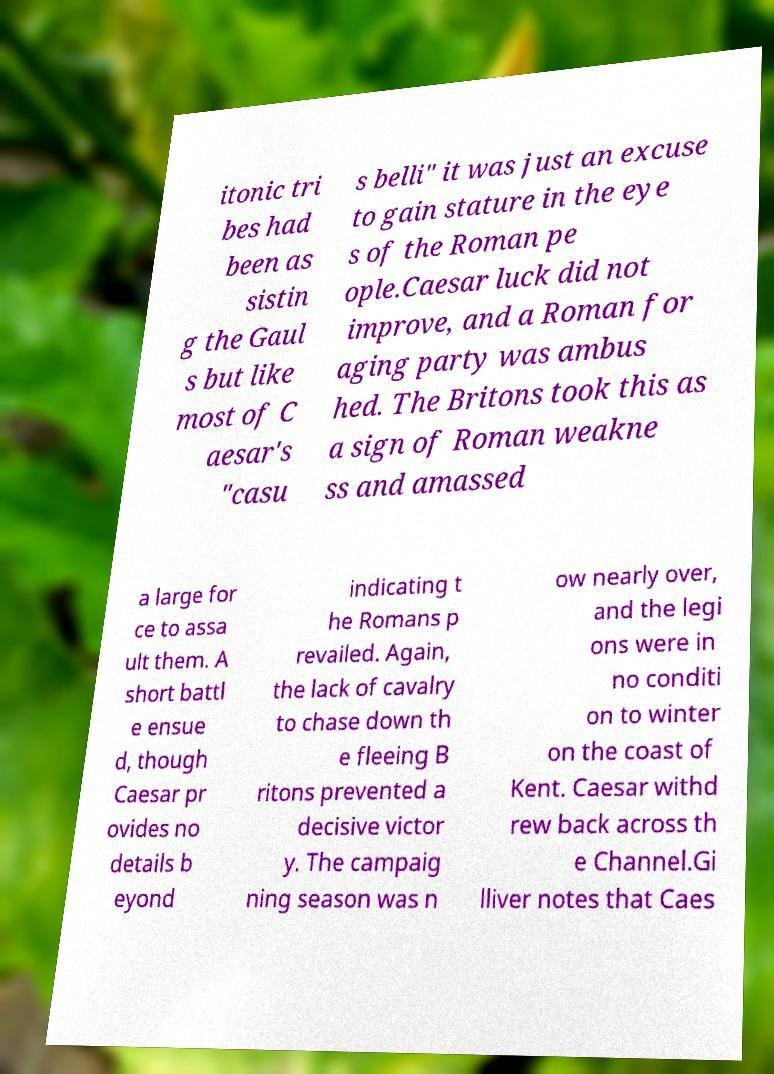For documentation purposes, I need the text within this image transcribed. Could you provide that? itonic tri bes had been as sistin g the Gaul s but like most of C aesar's "casu s belli" it was just an excuse to gain stature in the eye s of the Roman pe ople.Caesar luck did not improve, and a Roman for aging party was ambus hed. The Britons took this as a sign of Roman weakne ss and amassed a large for ce to assa ult them. A short battl e ensue d, though Caesar pr ovides no details b eyond indicating t he Romans p revailed. Again, the lack of cavalry to chase down th e fleeing B ritons prevented a decisive victor y. The campaig ning season was n ow nearly over, and the legi ons were in no conditi on to winter on the coast of Kent. Caesar withd rew back across th e Channel.Gi lliver notes that Caes 